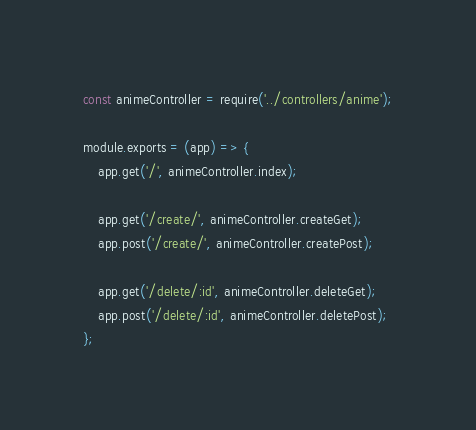Convert code to text. <code><loc_0><loc_0><loc_500><loc_500><_JavaScript_>const animeController = require('../controllers/anime');

module.exports = (app) => {
    app.get('/', animeController.index);

    app.get('/create/', animeController.createGet);
    app.post('/create/', animeController.createPost);

    app.get('/delete/:id', animeController.deleteGet);
    app.post('/delete/:id', animeController.deletePost);
};</code> 